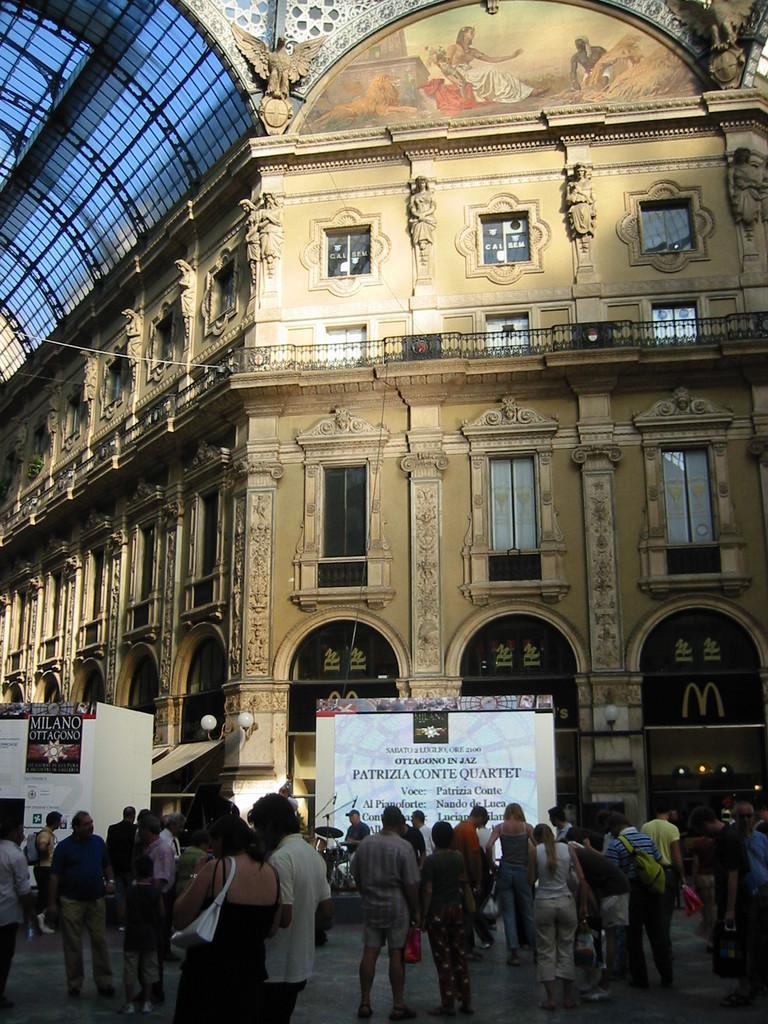In one or two sentences, can you explain what this image depicts? In the image we can see a building and these are the windows of the building. We can even see there are people standing, they are wearing clothes and some of them are carrying a bag on their back. This is a poster, light, a symbol and a footpath. 